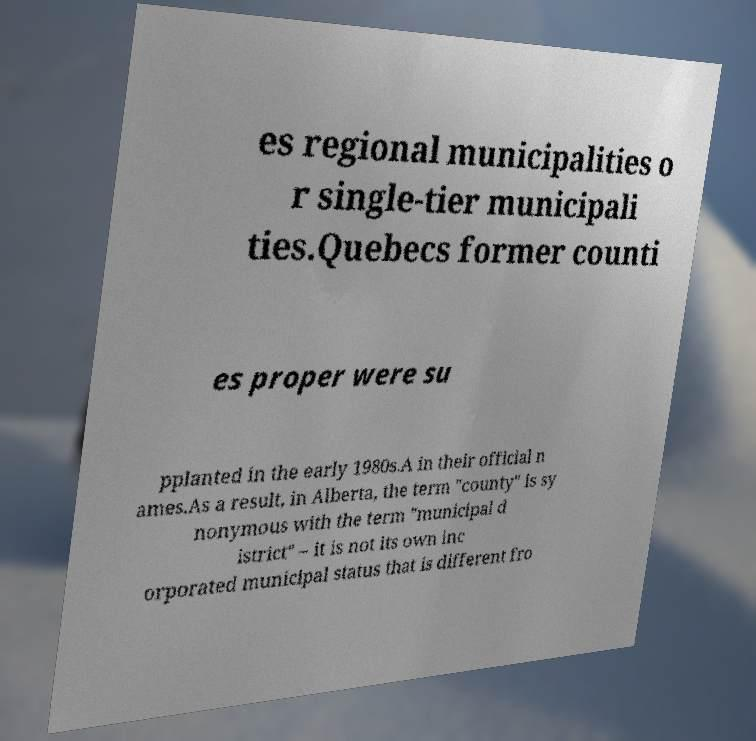Please identify and transcribe the text found in this image. es regional municipalities o r single-tier municipali ties.Quebecs former counti es proper were su pplanted in the early 1980s.A in their official n ames.As a result, in Alberta, the term "county" is sy nonymous with the term "municipal d istrict" – it is not its own inc orporated municipal status that is different fro 